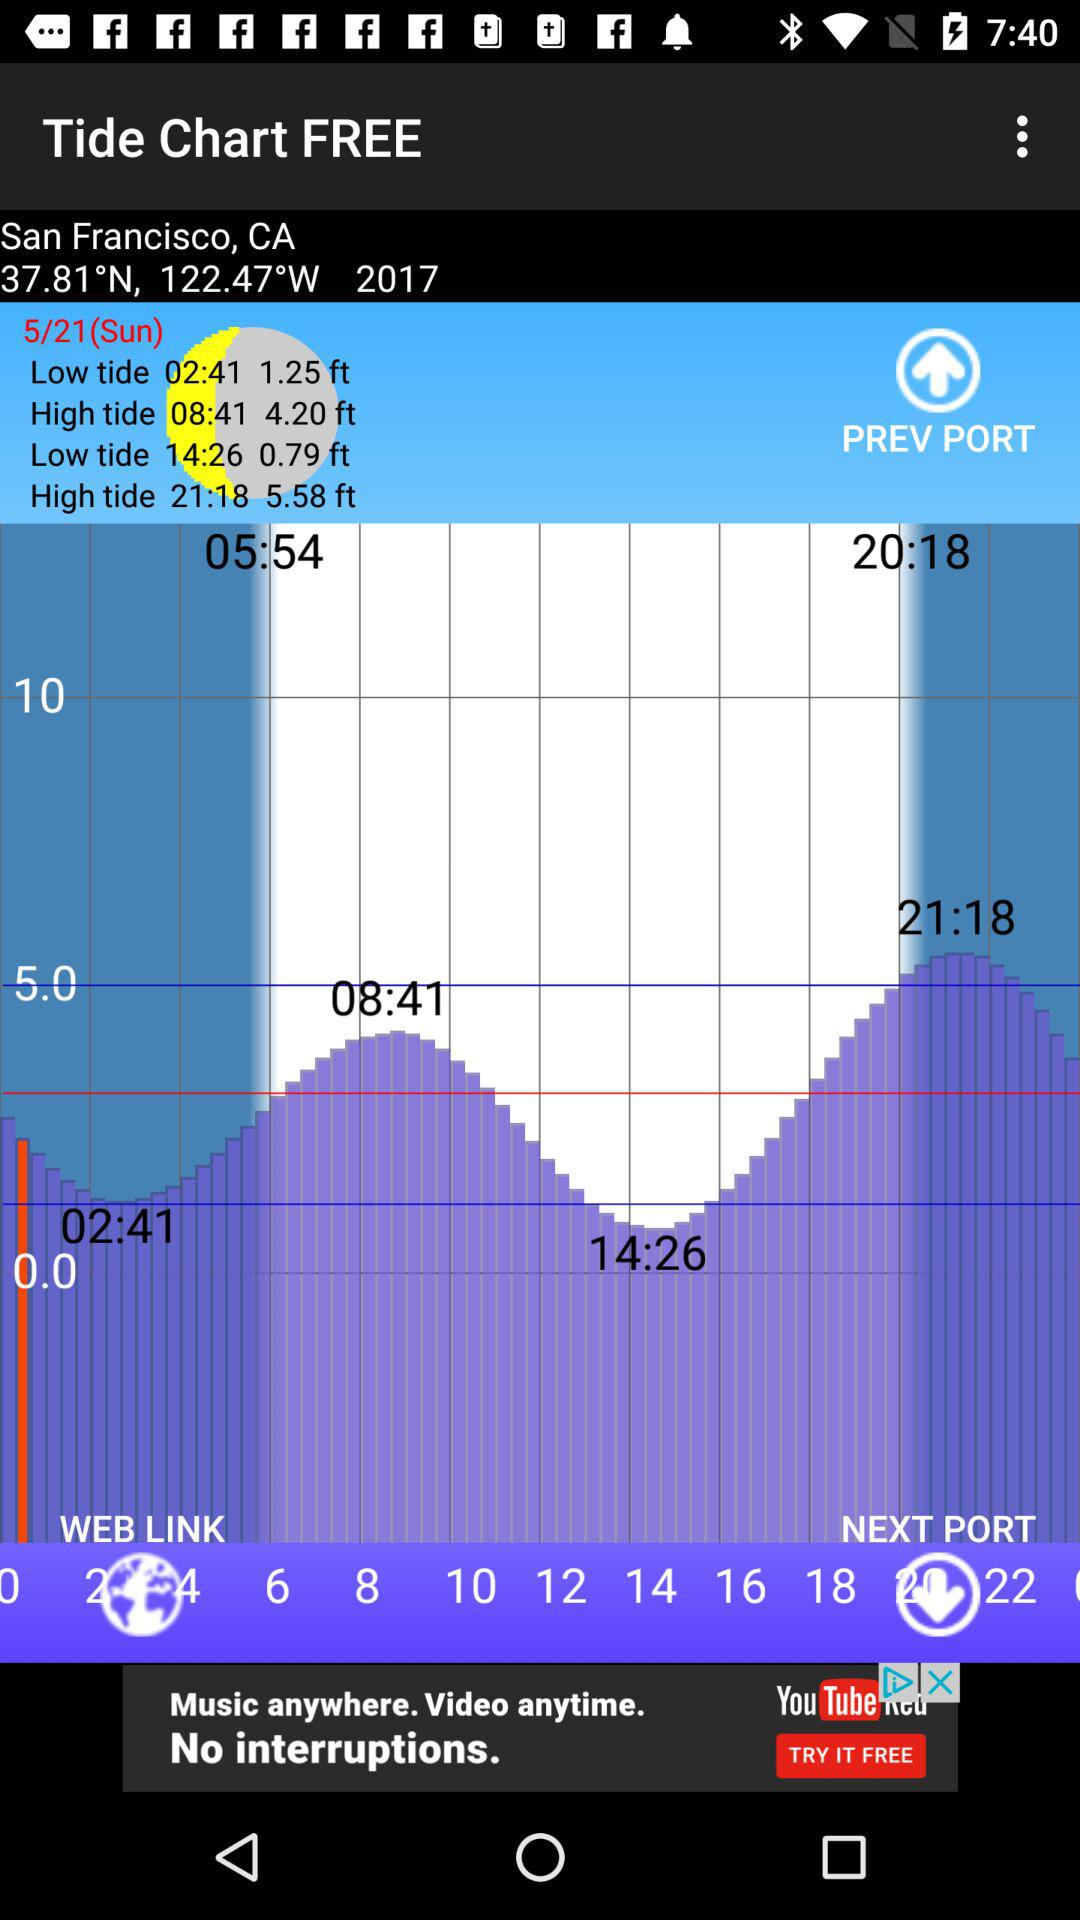What location is displayed on the screen? The location displayed on the screen is San Francisco, CA. 